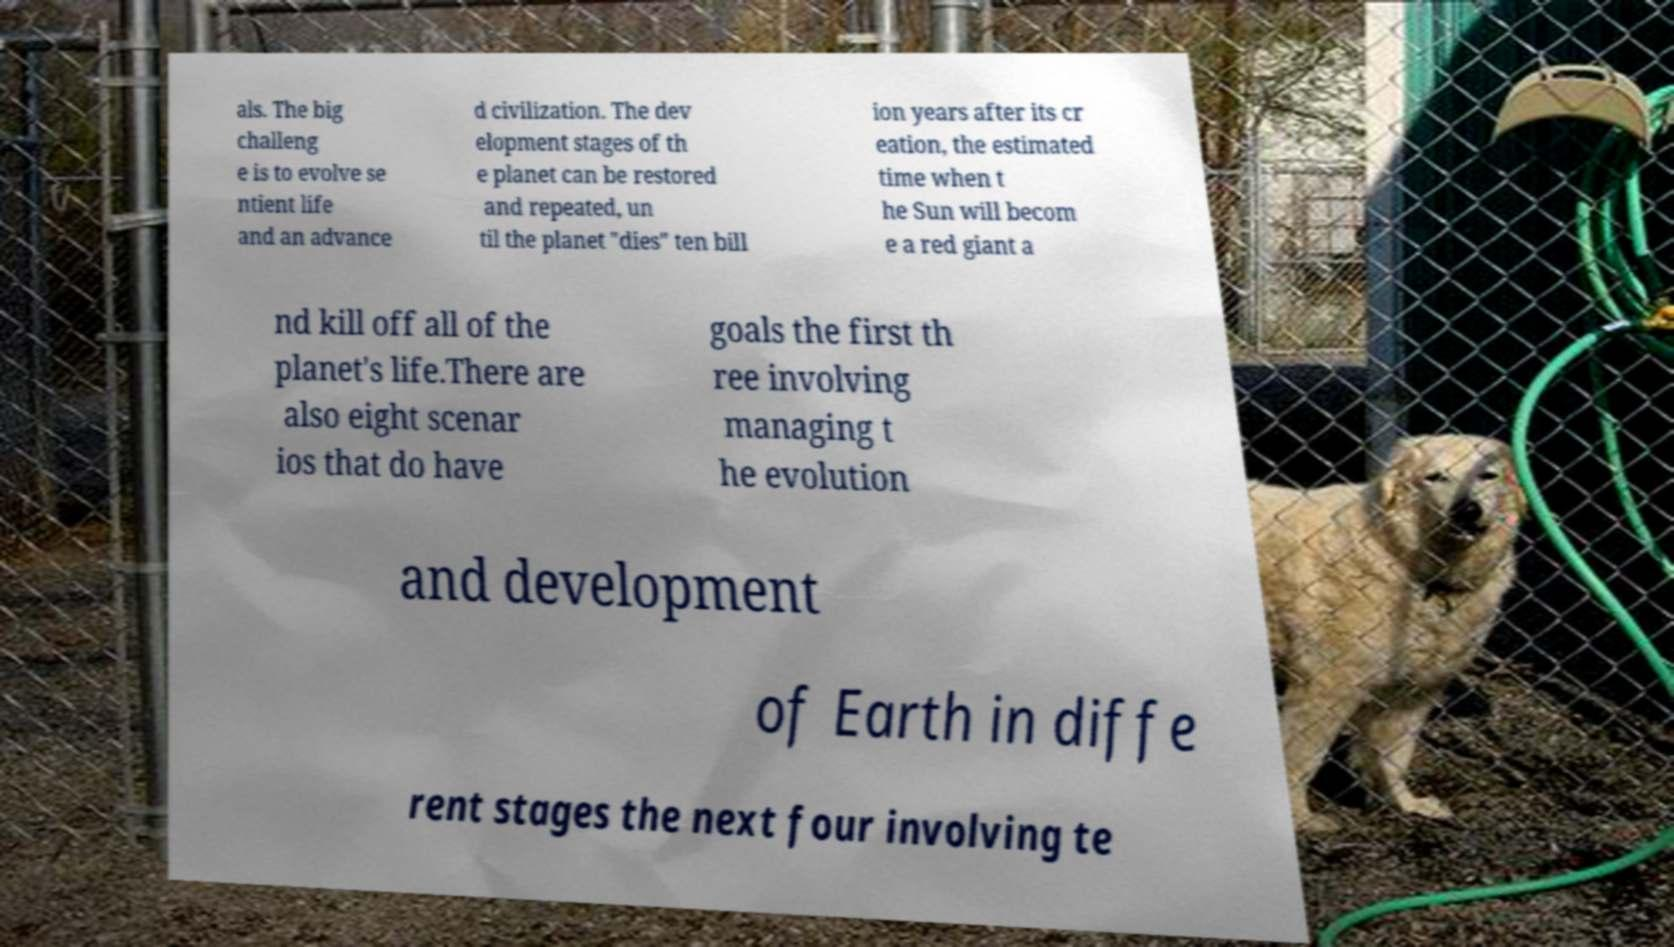I need the written content from this picture converted into text. Can you do that? als. The big challeng e is to evolve se ntient life and an advance d civilization. The dev elopment stages of th e planet can be restored and repeated, un til the planet "dies" ten bill ion years after its cr eation, the estimated time when t he Sun will becom e a red giant a nd kill off all of the planet's life.There are also eight scenar ios that do have goals the first th ree involving managing t he evolution and development of Earth in diffe rent stages the next four involving te 